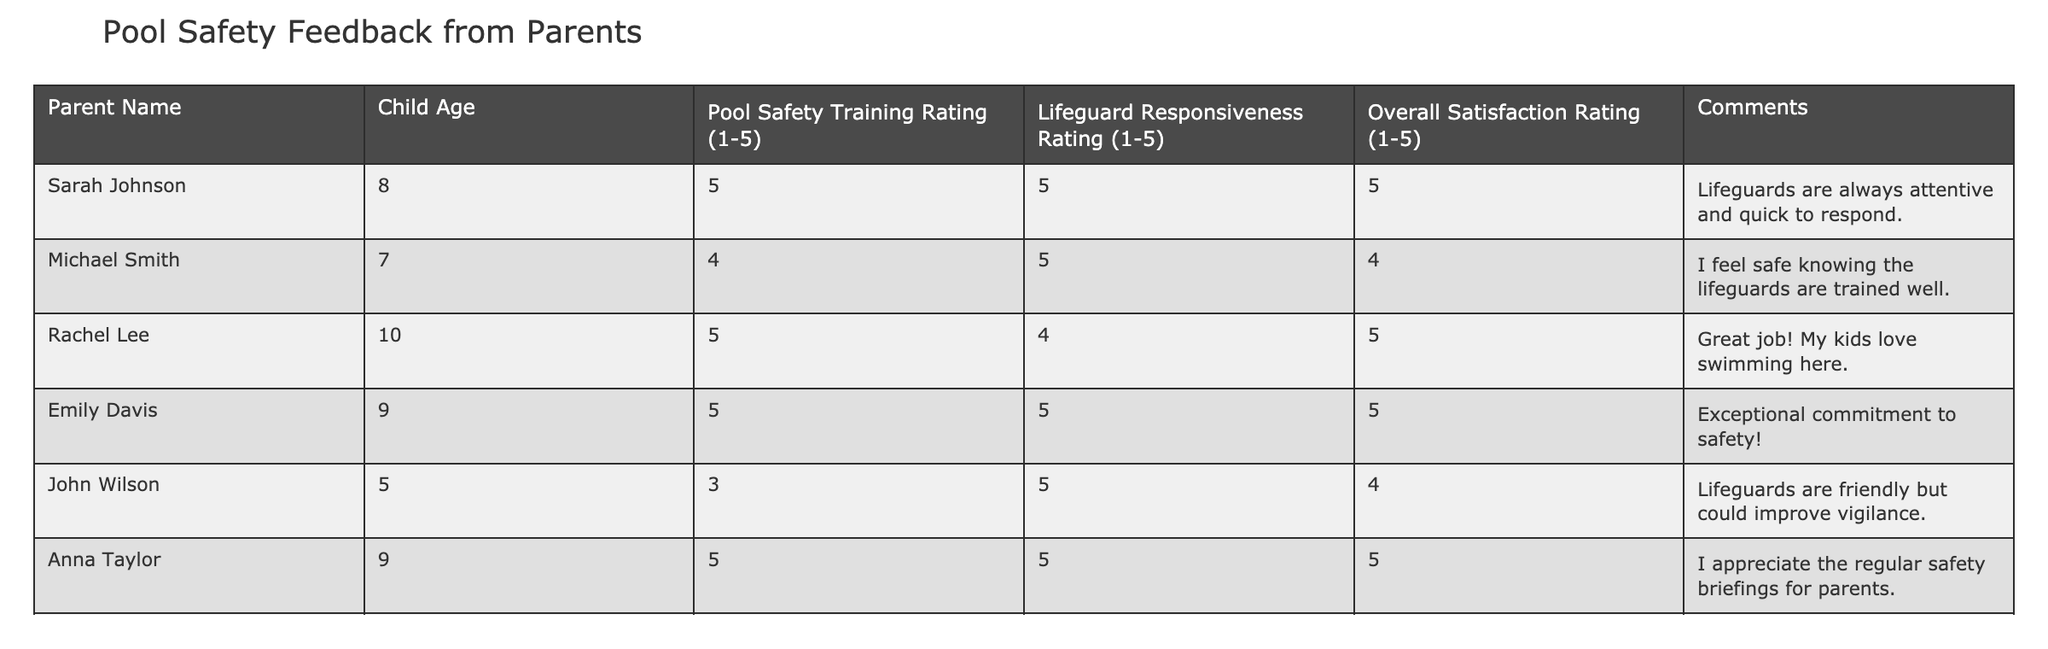What is the highest Overall Satisfaction Rating given by parents? The Overall Satisfaction Ratings provided range from 4 to 5. By checking the rating values, the maximum is 5, given by multiple parents.
Answer: 5 What is the average Lifeguard Responsiveness Rating? The Lifeguard Responsiveness Ratings are 5, 5, 4, 5, 5, and 5. To find the average: (5 + 5 + 4 + 5 + 5 + 5) / 6 = 29 / 6 = 4.83 (rounded to two decimal places).
Answer: 4.83 How many parents rated the Pool Safety Training as 5? By reviewing the ratings, there are four entries (Sarah Johnson, Rachel Lee, Emily Davis, and Anna Taylor) who rated Pool Safety Training as 5.
Answer: 4 Is there any parent who is not fully satisfied (rating less than 5) with the Overall Satisfaction? John Wilson rated Overall Satisfaction as 4, which is less than 5, indicating he is not fully satisfied.
Answer: Yes Which parent gave the highest rating for Lifeguard Responsiveness? Sarah Johnson, Michael Smith, and multiple others rated Lifeguard Responsiveness as 5, which is the highest rating.
Answer: Sarah Johnson and others What is the sum of ratings for Pool Safety Training across all parents? The ratings for Pool Safety Training are 5, 4, 5, 5, 3, and 5. Summing these up: 5 + 4 + 5 + 5 + 3 + 5 = 27.
Answer: 27 How many comments express gratitude towards the lifeguards? Looking through the comments, Sarah Johnson, Emily Davis, and Anna Taylor explicitly express gratitude towards the lifeguards’ dedication. This makes three comments appreciative of the lifeguards.
Answer: 3 If a parent rated Pool Safety Training as 3, how satisfied were they overall? John Wilson rated Pool Safety Training as 3 and Overall Satisfaction as 4. This indicates that even with a lesser rating for training, he still felt a decent level of satisfaction overall.
Answer: 4 What percentage of parents are fully satisfied (5 rating) with both Pool Safety Training and Overall Satisfaction? Out of six parents, four rated Pool Safety Training as 5, and three among them also gave Overall Satisfaction as 5. Therefore, the percentage is (3/6) * 100 = 50%.
Answer: 50% How does the average Pool Safety Training rating compare to Lifeguard Responsiveness? The average for Pool Safety Training is (5 + 4 + 5 + 5 + 3 + 5) / 6 = 4.83, while Lifeguard Responsiveness averages to 4.83 as well; they are equal.
Answer: They are equal 